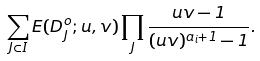<formula> <loc_0><loc_0><loc_500><loc_500>\sum _ { J \subset I } E ( D _ { J } ^ { o } ; u , v ) \prod _ { J } \frac { u v - 1 } { ( u v ) ^ { a _ { i } + 1 } - 1 } .</formula> 